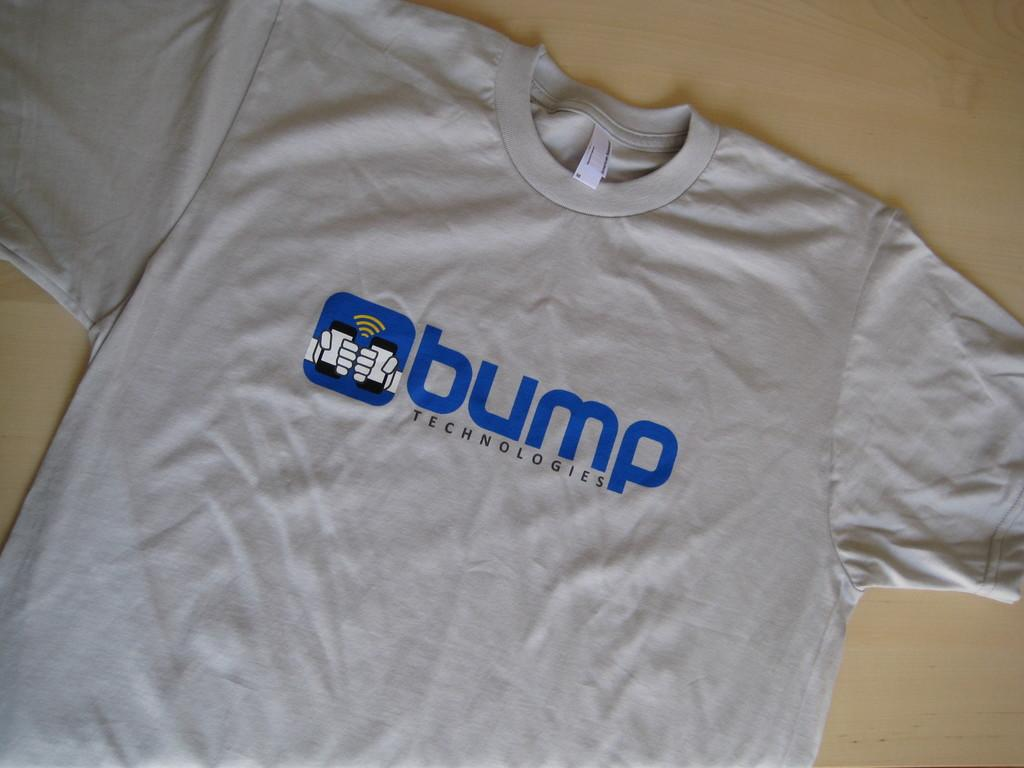<image>
Share a concise interpretation of the image provided. A grey tshirt with the word Bump on it. 